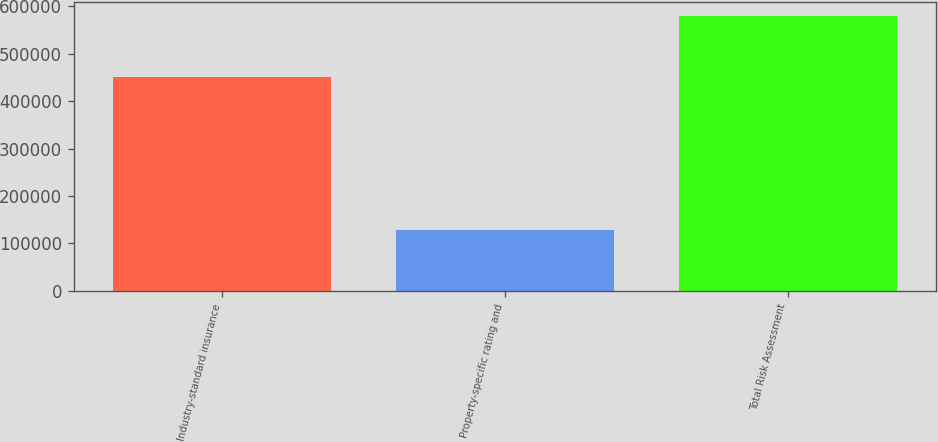Convert chart. <chart><loc_0><loc_0><loc_500><loc_500><bar_chart><fcel>Industry-standard insurance<fcel>Property-specific rating and<fcel>Total Risk Assessment<nl><fcel>450646<fcel>128860<fcel>579506<nl></chart> 